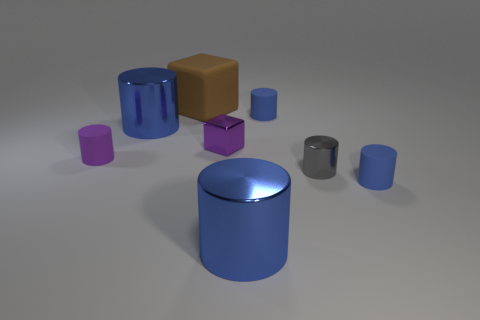How many blue cylinders must be subtracted to get 1 blue cylinders? 3 Subtract 1 cylinders. How many cylinders are left? 5 Add 1 tiny blue matte cylinders. How many objects exist? 9 Subtract all gray cylinders. How many cylinders are left? 5 Subtract all small cylinders. How many cylinders are left? 2 Subtract all purple metallic spheres. Subtract all small purple rubber cylinders. How many objects are left? 7 Add 4 small metallic things. How many small metallic things are left? 6 Add 6 tiny purple shiny objects. How many tiny purple shiny objects exist? 7 Subtract 0 gray cubes. How many objects are left? 8 Subtract all cylinders. How many objects are left? 2 